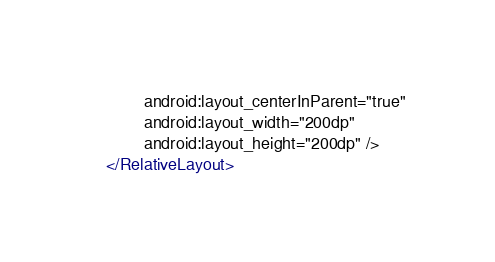<code> <loc_0><loc_0><loc_500><loc_500><_XML_>        android:layout_centerInParent="true"
        android:layout_width="200dp"
        android:layout_height="200dp" />
</RelativeLayout></code> 